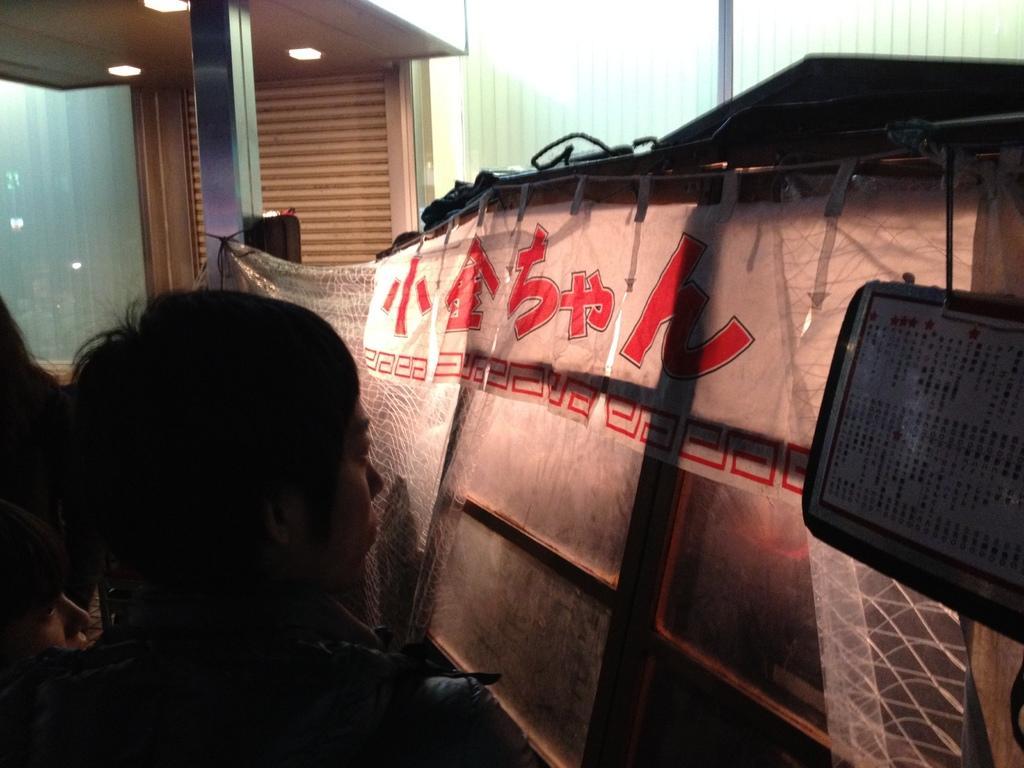Describe this image in one or two sentences. In this image there are a few people standing, in front of them there is a curtain, behind that there is something. In the background there is a wall and a pillar. At the top of the image there is a ceiling with lights. 